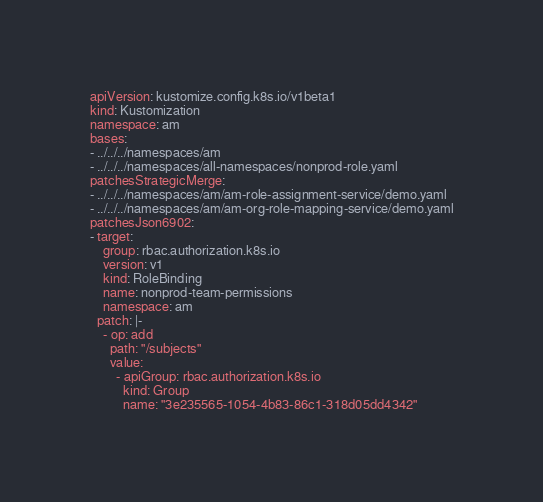Convert code to text. <code><loc_0><loc_0><loc_500><loc_500><_YAML_>apiVersion: kustomize.config.k8s.io/v1beta1
kind: Kustomization
namespace: am
bases:
- ../../../namespaces/am
- ../../../namespaces/all-namespaces/nonprod-role.yaml
patchesStrategicMerge:
- ../../../namespaces/am/am-role-assignment-service/demo.yaml
- ../../../namespaces/am/am-org-role-mapping-service/demo.yaml
patchesJson6902:
- target:
    group: rbac.authorization.k8s.io
    version: v1
    kind: RoleBinding
    name: nonprod-team-permissions
    namespace: am
  patch: |-
    - op: add
      path: "/subjects"
      value:
        - apiGroup: rbac.authorization.k8s.io
          kind: Group
          name: "3e235565-1054-4b83-86c1-318d05dd4342"</code> 